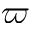<formula> <loc_0><loc_0><loc_500><loc_500>\varpi</formula> 